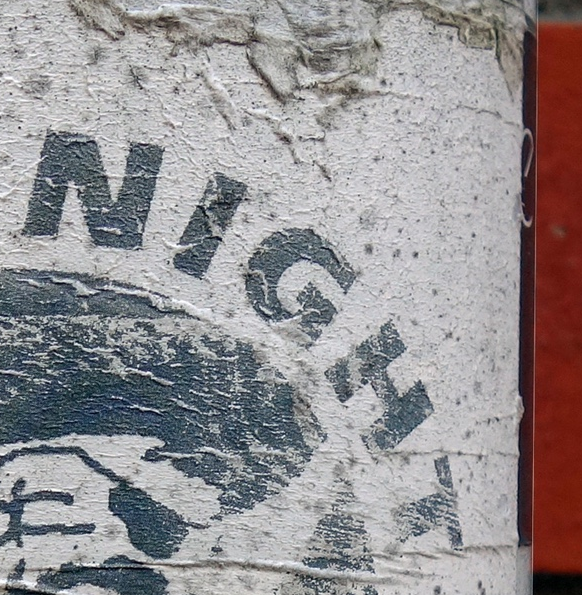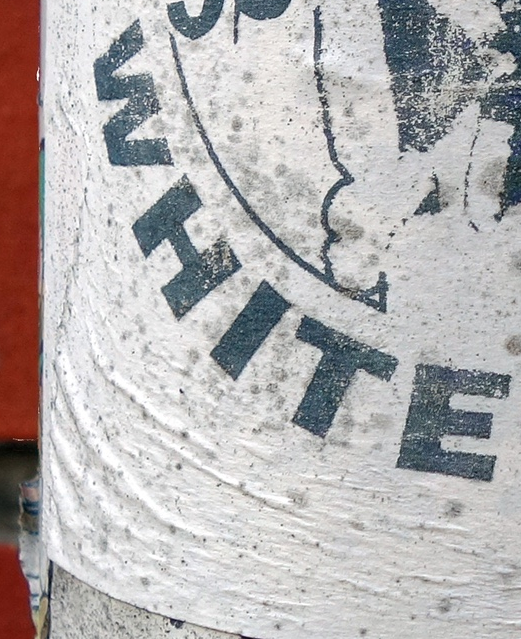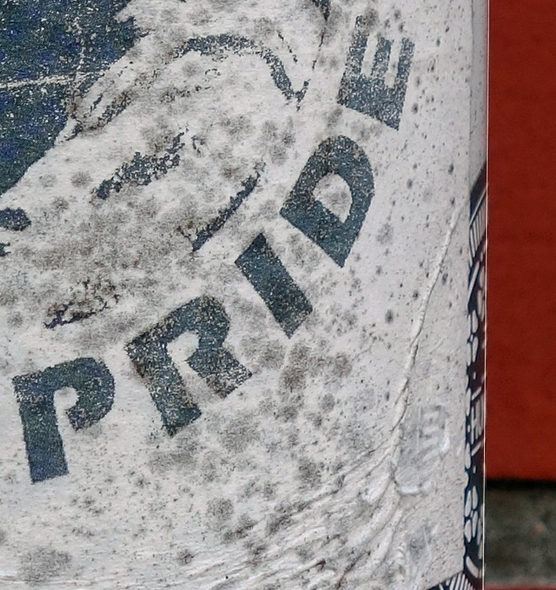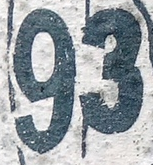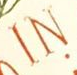Read the text content from these images in order, separated by a semicolon. NIGHT; WHITE; PRIDE; 93; IN 